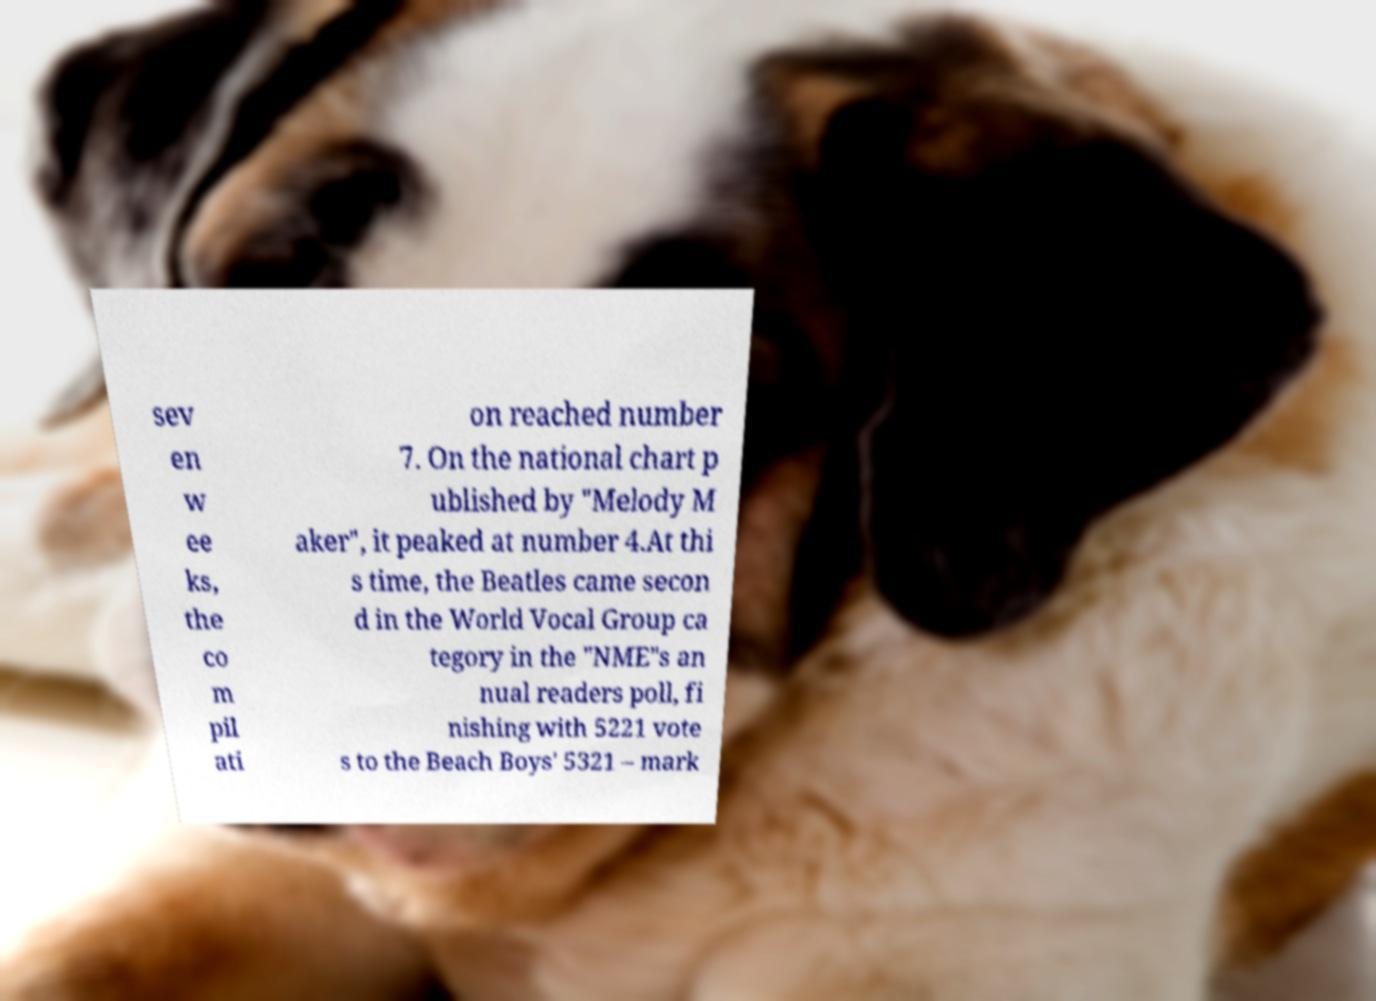Please identify and transcribe the text found in this image. sev en w ee ks, the co m pil ati on reached number 7. On the national chart p ublished by "Melody M aker", it peaked at number 4.At thi s time, the Beatles came secon d in the World Vocal Group ca tegory in the "NME"s an nual readers poll, fi nishing with 5221 vote s to the Beach Boys' 5321 – mark 